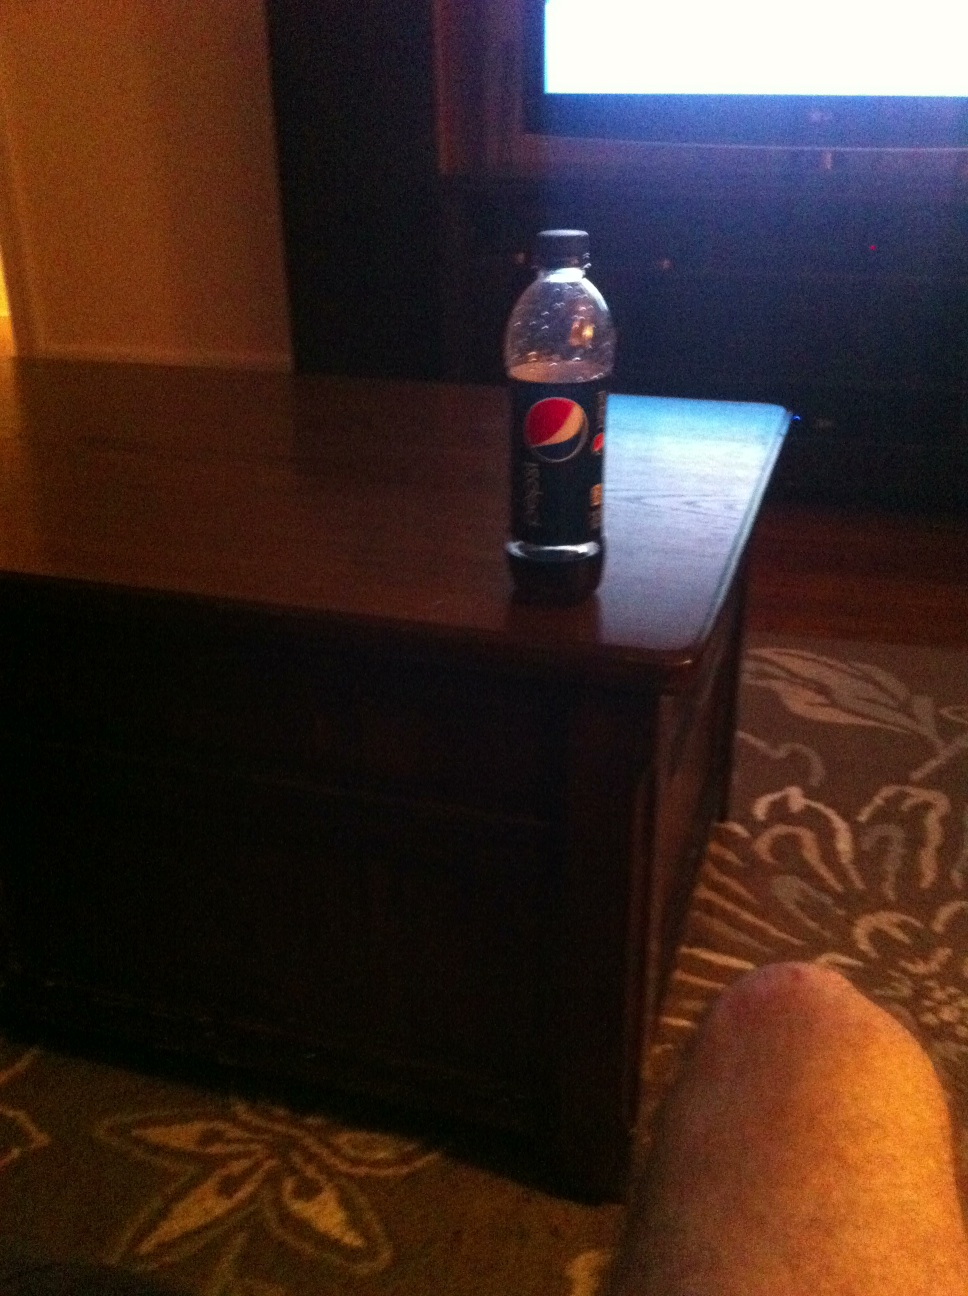What does the presence of this bottle in the setting tell us about the person's activity? The presence of the Pepsi bottle, along with the casual setting of a living room and a visible TV, indicates that the person might be spending time relaxing or enjoying entertainment, such as watching a movie or a sports event. 